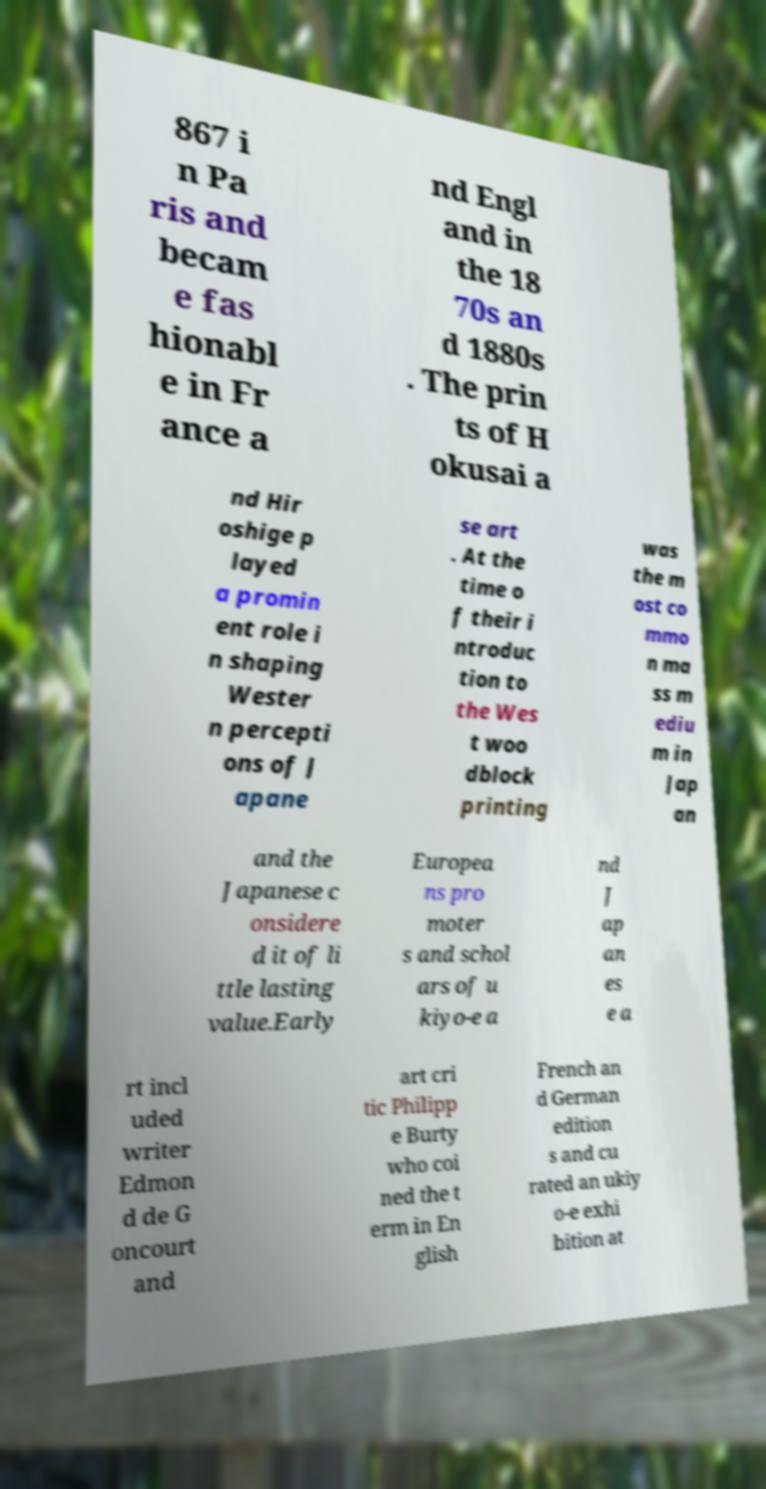Could you assist in decoding the text presented in this image and type it out clearly? 867 i n Pa ris and becam e fas hionabl e in Fr ance a nd Engl and in the 18 70s an d 1880s . The prin ts of H okusai a nd Hir oshige p layed a promin ent role i n shaping Wester n percepti ons of J apane se art . At the time o f their i ntroduc tion to the Wes t woo dblock printing was the m ost co mmo n ma ss m ediu m in Jap an and the Japanese c onsidere d it of li ttle lasting value.Early Europea ns pro moter s and schol ars of u kiyo-e a nd J ap an es e a rt incl uded writer Edmon d de G oncourt and art cri tic Philipp e Burty who coi ned the t erm in En glish French an d German edition s and cu rated an ukiy o-e exhi bition at 